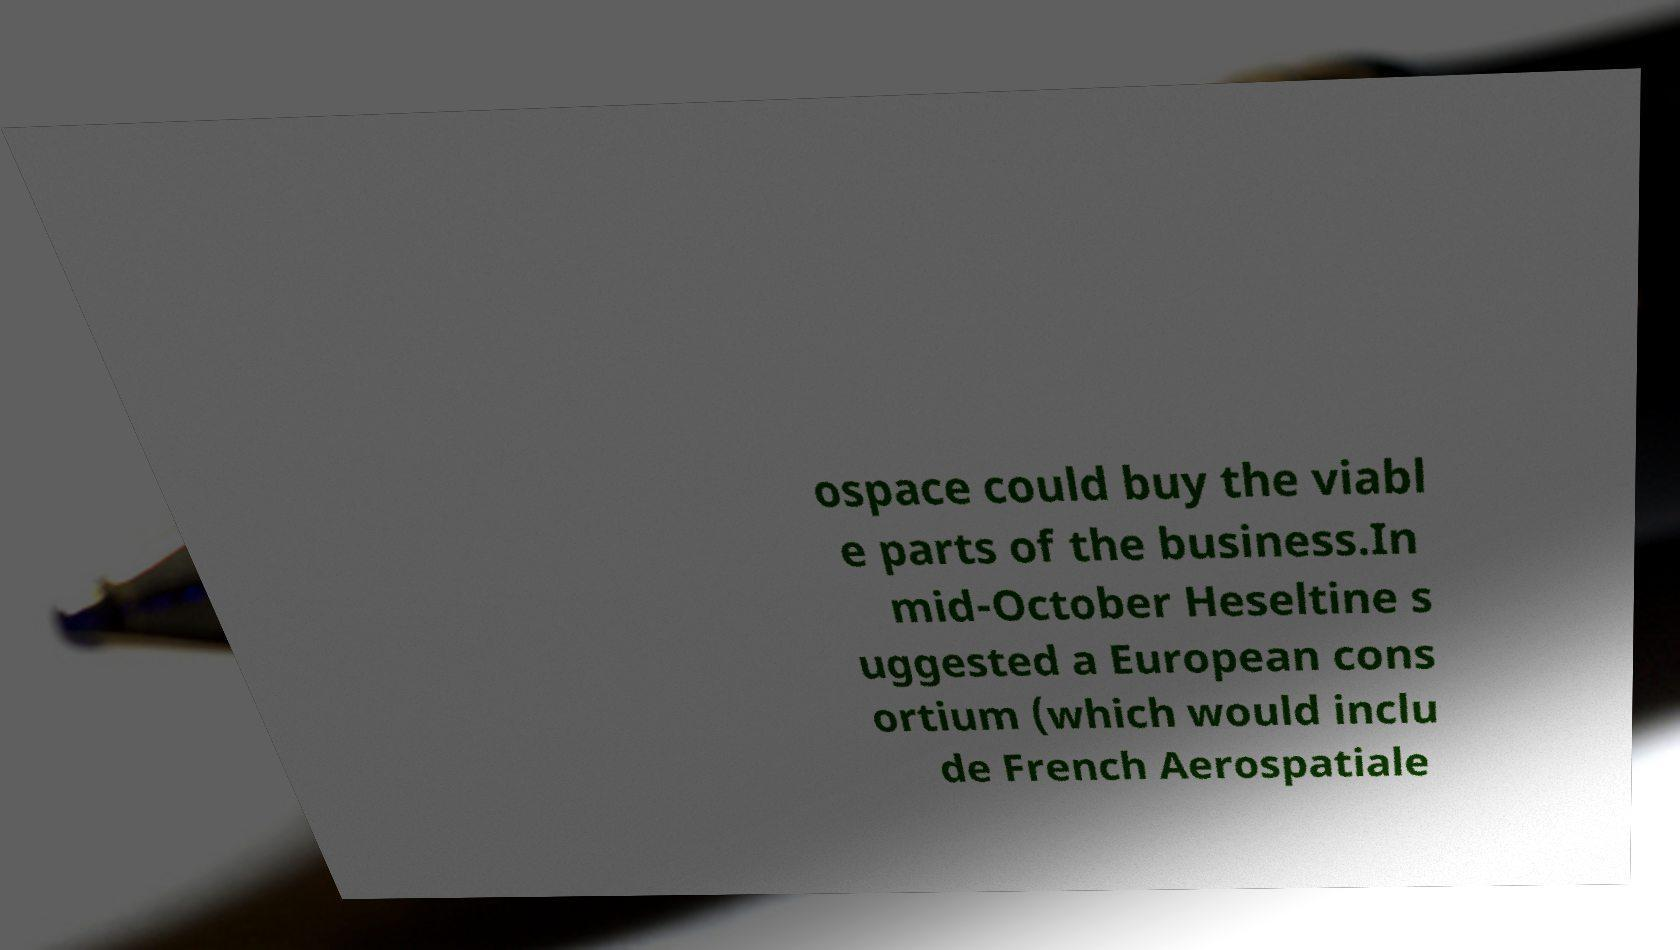There's text embedded in this image that I need extracted. Can you transcribe it verbatim? ospace could buy the viabl e parts of the business.In mid-October Heseltine s uggested a European cons ortium (which would inclu de French Aerospatiale 